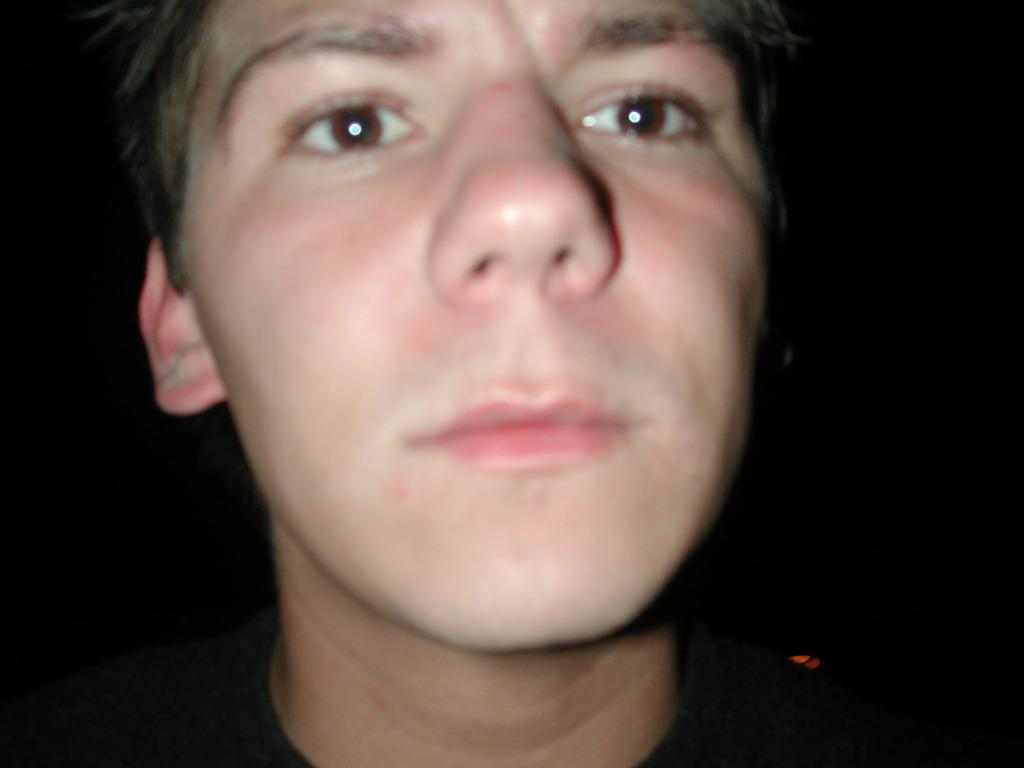What is the main subject of the image? The main subject of the image is a man's face. How much of the man's body is visible in the image? The man's face is visible till his shoulders in the image. What is the man wearing in the image? The man is wearing a black T-shirt in the image. What can be observed about the background of the image? The background of the image is dark. How many geese are visible in the image? There are no geese present in the image. What type of building can be seen in the background of the image? There is no building visible in the image; the background is dark. 